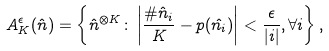<formula> <loc_0><loc_0><loc_500><loc_500>A _ { K } ^ { \epsilon } ( \hat { n } ) = \left \{ \hat { n } ^ { \otimes K } \colon \left | \frac { \# \hat { n } _ { i } } { K } - p ( \hat { n _ { i } } ) \right | < \frac { \epsilon } { | i | } , \forall i \right \} ,</formula> 